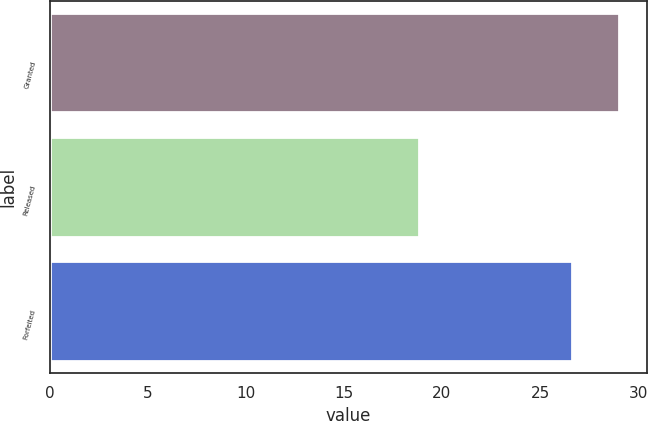<chart> <loc_0><loc_0><loc_500><loc_500><bar_chart><fcel>Granted<fcel>Released<fcel>Forfeited<nl><fcel>29<fcel>18.82<fcel>26.62<nl></chart> 